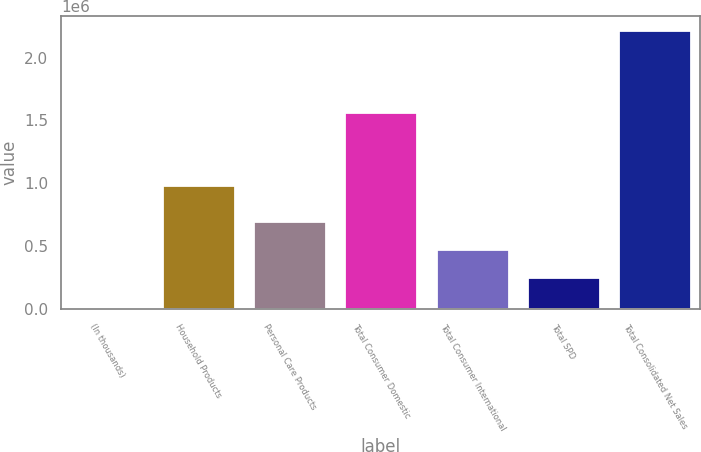<chart> <loc_0><loc_0><loc_500><loc_500><bar_chart><fcel>(In thousands)<fcel>Household Products<fcel>Personal Care Products<fcel>Total Consumer Domestic<fcel>Total Consumer International<fcel>Total SPD<fcel>Total Consolidated Net Sales<nl><fcel>2007<fcel>991141<fcel>702311<fcel>1.5639e+06<fcel>480417<fcel>258524<fcel>2.22094e+06<nl></chart> 